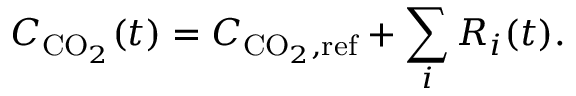Convert formula to latex. <formula><loc_0><loc_0><loc_500><loc_500>C _ { C O _ { 2 } } ( t ) = C _ { C O _ { 2 } , r e f } + \sum _ { i } R _ { i } ( t ) .</formula> 